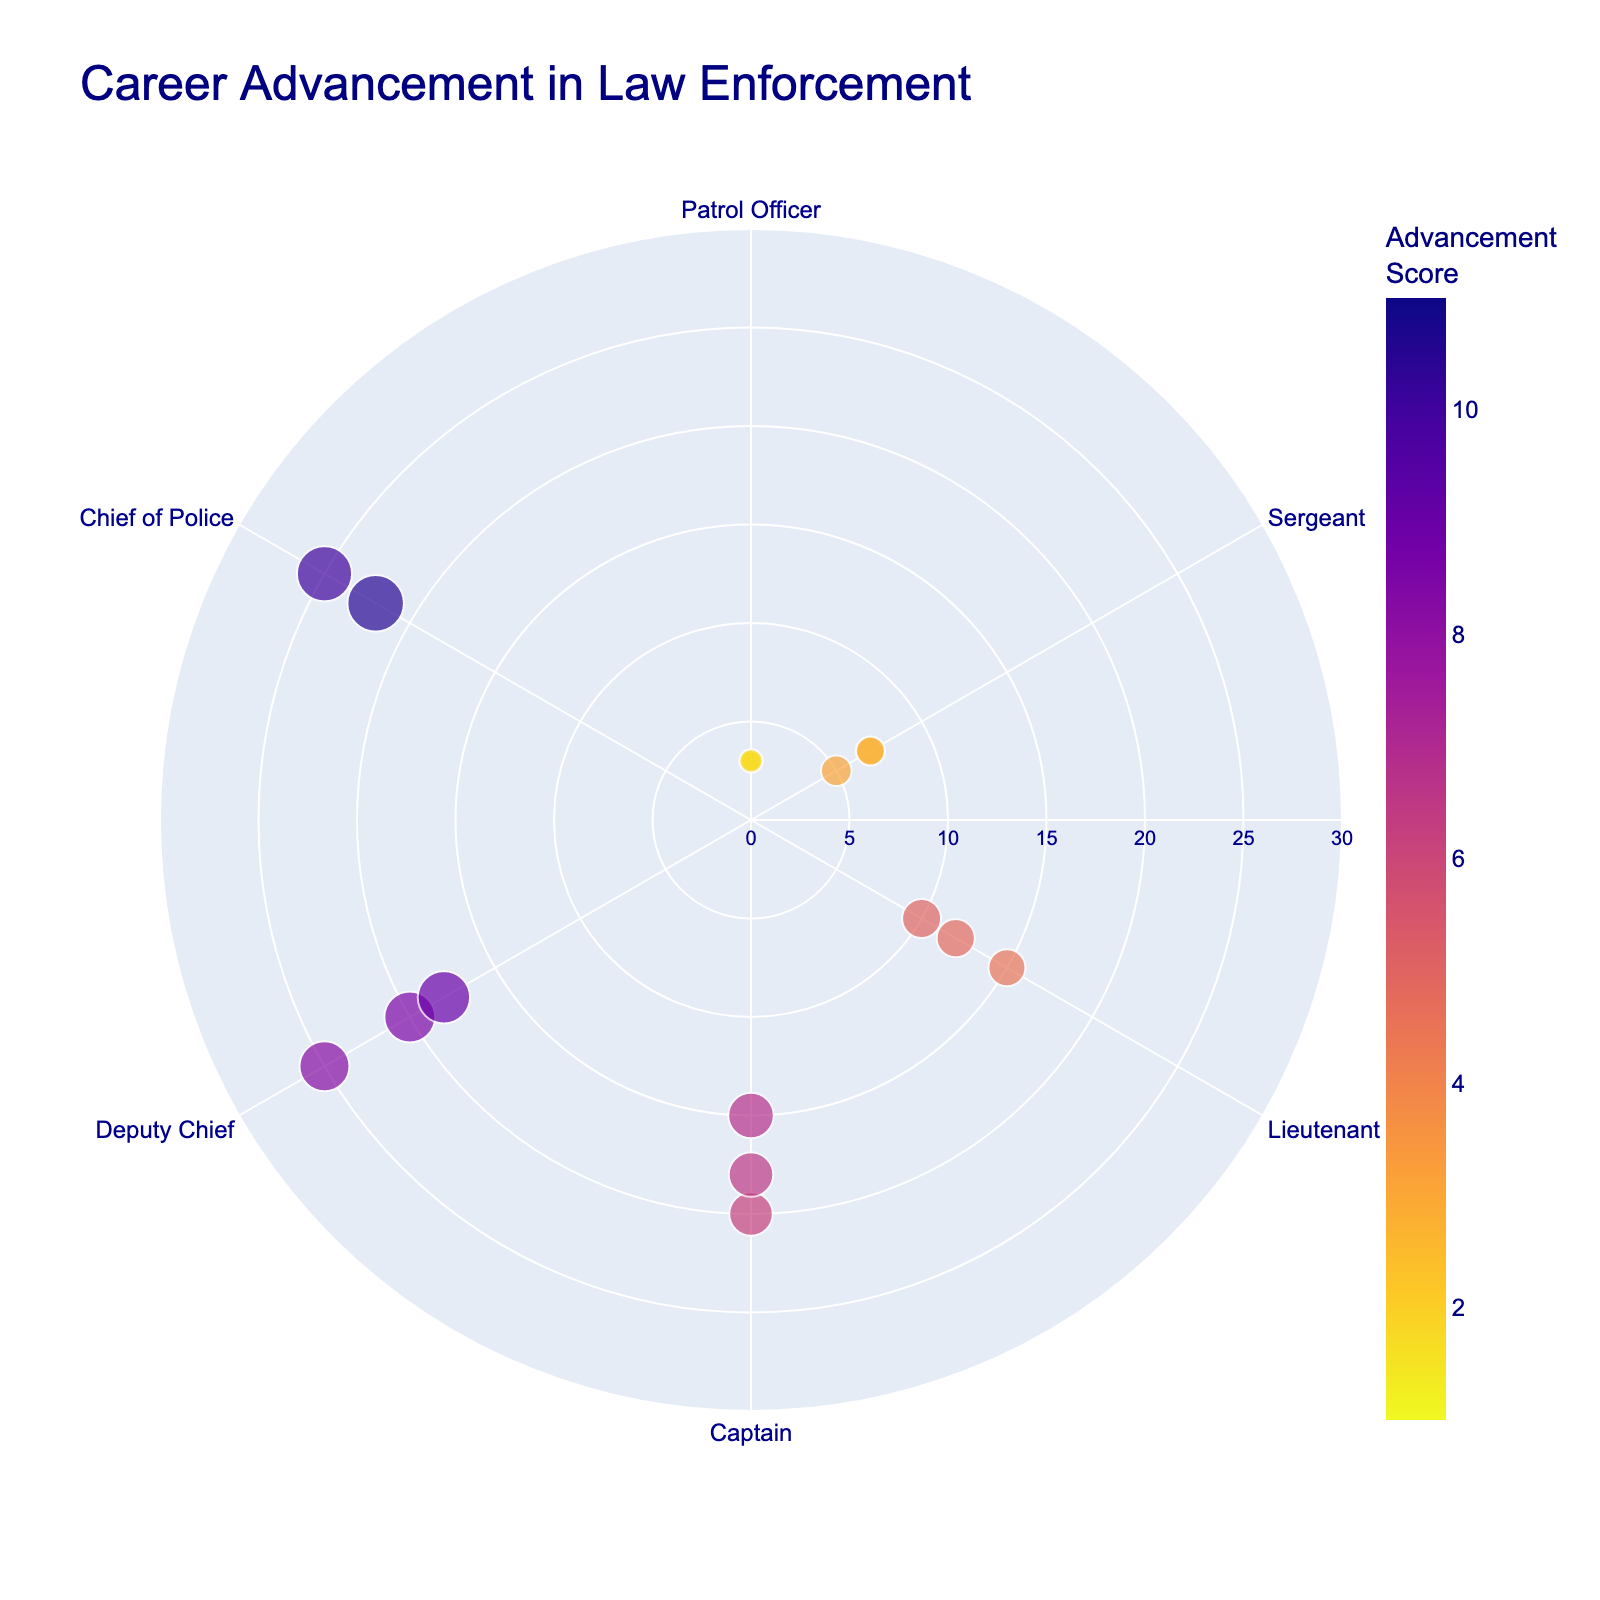What is the title of the polar scatter chart? The title is located at the top of the figure and is presented in a font size of 24 with a color of navy.
Answer: Career Advancement in Law Enforcement What is the range of the radial axis in the plot? The radial axis shows the range starting from 0 up to 30, as specified in the customization of the plot layout.
Answer: 0 to 30 Which rank has the highest Advancement Score? By inspecting the position related to different ranks and the largest size, the Chief of Police rank has the highest Advancement Score.
Answer: Chief of Police How many data points have a Bachelor's Degree as the education level? By checking the hover information on the scatter points in the plot, there are six data points with a Bachelor’s Degree.
Answer: Six Which education level has the maximum Advancement Score for the Deputy Chief rank? By looking at the hover information and identifying the size and color, the Master's Degree in the Deputy Chief rank has the maximum score.
Answer: Master's Degree How does the average Advancement Score compare between Sergeants with High School Diplomas and Bachelor's Degrees? To find the average, add the scores of Sergeants with High School Diplomas (2.5) and those with Bachelor's Degrees (3.1) and then divide by their respective counts (1 each).
Answer: High School Diploma: 2.5, Bachelor's Degree: 3.1 Which rank has the highest concentration of data points? By observing the distribution of points along the radial axis, the Patrol Officer rank has the highest concentration of data points.
Answer: Patrol Officer Is there any rank with no associated Master’s Degree? By looking at the education levels in the hover information for all ranks except Chief of Police and Deputy Chief, no other rank has an associated Master’s Degree.
Answer: Yes What is the difference in the Advancement Score between the highest and lowest values for Captain rank points? The highest Advancement Score for Captain rank is 6.8 (Bachelor's Degree) and the lowest is 6.2 (High School Diploma). The difference is 6.8 - 6.2.
Answer: 0.6 Compare the average years of service for Lieutenants with a High School Diploma versus Bachelor's Degree. Calculate the average years based on the given years of service (15 for High School Diploma and 10 for Bachelor's Degree).
Answer: High School Diploma: 15, Bachelor's Degree: 10 